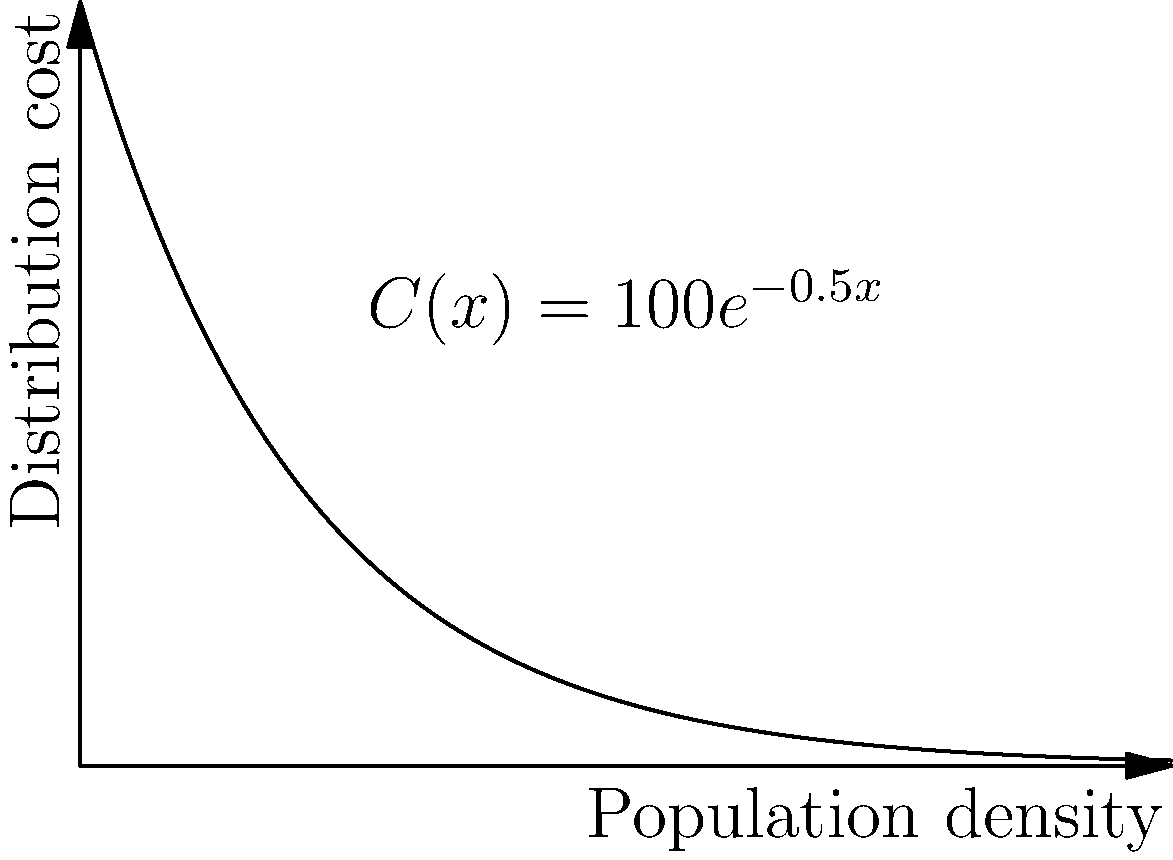The graph shows the relationship between population density (x) and vaccine distribution cost (C) for a region, modeled by the function $C(x) = 100e^{-0.5x}$, where x is measured in thousands of people per square kilometer and C is in dollars per dose. If the total area of the region is 1000 km², and you need to distribute 1 million doses, at what population density should you focus distribution efforts to minimize the total cost? To solve this optimization problem, we need to follow these steps:

1) The total cost T is the product of the cost per dose C(x) and the number of doses:
   $T = 1,000,000 \cdot C(x) = 1,000,000 \cdot 100e^{-0.5x} = 10^8 e^{-0.5x}$

2) The population density x is related to the total population P and area A:
   $x = \frac{P}{A}$, where A = 1000 km²

3) The total population P is the product of density and area:
   $P = 1000x$

4) To minimize T, we need to find where its derivative is zero:
   $\frac{dT}{dx} = 10^8 \cdot (-0.5) \cdot e^{-0.5x} = -5 \cdot 10^7 e^{-0.5x}$

5) Setting this equal to zero:
   $-5 \cdot 10^7 e^{-0.5x} = 0$

6) This is always negative for finite x, meaning there's no interior minimum.

7) Therefore, we should distribute at the highest possible density, which is when the entire population of 1 million is in the 1000 km² area.

8) The optimal density is thus:
   $x = \frac{1,000,000}{1000} = 1000$ people per km²
Answer: 1 thousand people per square kilometer 